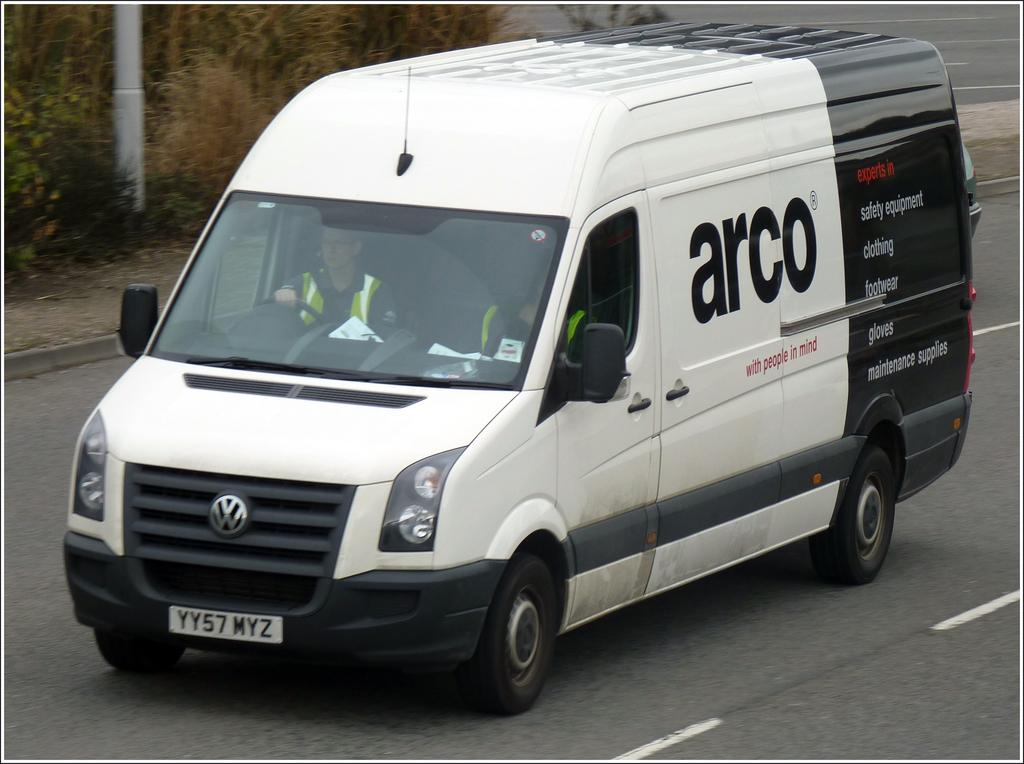Provide a one-sentence caption for the provided image. A black-and-white van labeled with the company name "Arco" drives down a road. 